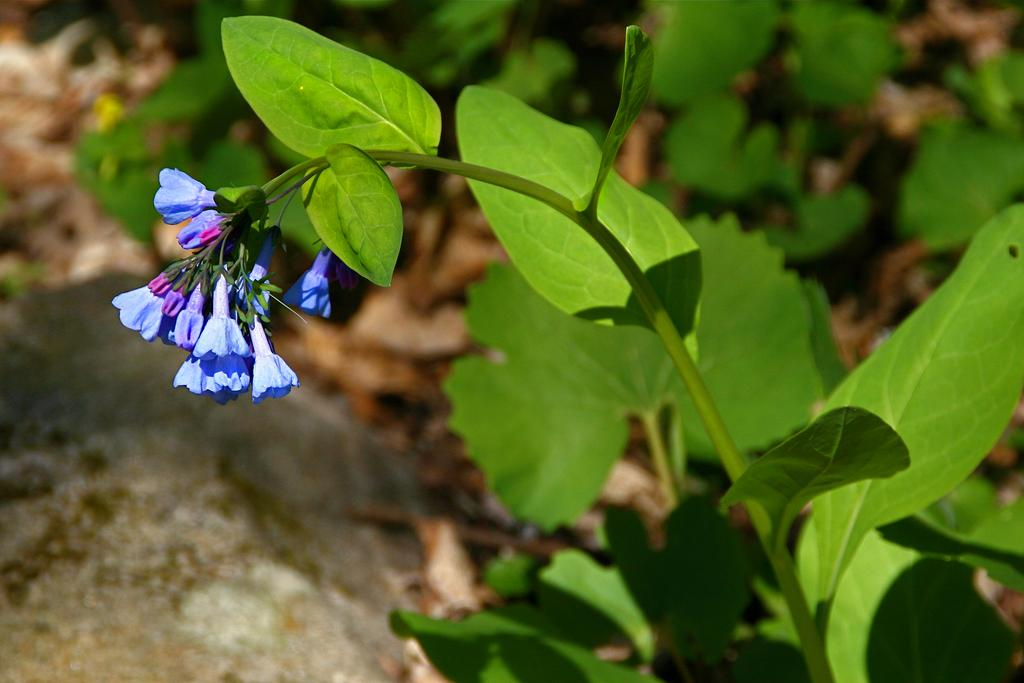What types of living organisms can be seen in the image? Plants and flowers are visible in the image. Can you describe any specific features of the plants? There is a rock towards the bottom of the image. How would you describe the overall appearance of the image? The background of the image is blurred. What type of operation is being performed on the geese in the image? There are no geese present in the image, so no operation is being performed. What scientific theory is being demonstrated by the plants in the image? The image does not depict a scientific theory; it simply shows plants and flowers. 